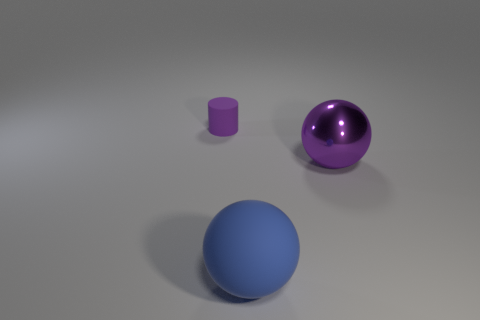Add 3 big objects. How many objects exist? 6 Subtract all spheres. How many objects are left? 1 Subtract 0 yellow cylinders. How many objects are left? 3 Subtract all matte cylinders. Subtract all rubber objects. How many objects are left? 0 Add 1 small rubber things. How many small rubber things are left? 2 Add 1 tiny cylinders. How many tiny cylinders exist? 2 